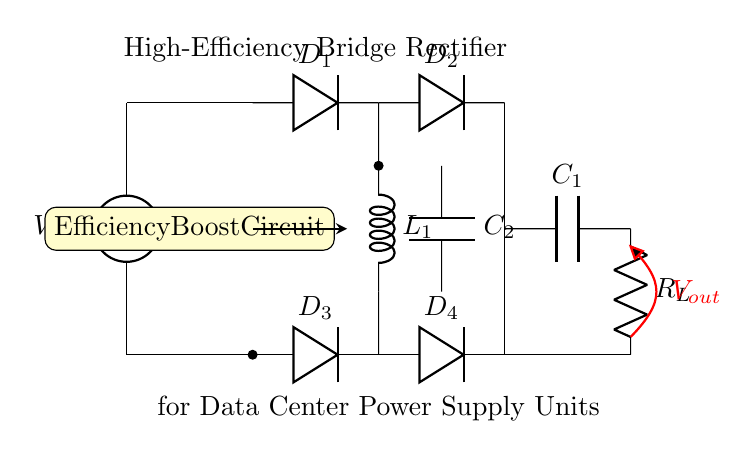What type of rectifier is shown in the circuit? The circuit features a bridge rectifier, which uses four diodes to convert AC voltage to DC voltage.
Answer: bridge rectifier How many diodes are in this circuit? The circuit shows a total of four diodes, labeled D1, D2, D3, and D4, which are part of the bridge rectifier configuration.
Answer: four What component is used for smoothing the output voltage? The smoothing is performed by the capacitor labeled C1, which helps reduce ripple in the output voltage.
Answer: C1 What is the purpose of the component labeled L1? L1 is an inductor which is utilized to enhance the efficiency of the rectifier by reducing the ripple current for better performance.
Answer: efficiency enhancement What is the function of the load resistor R_L? R_L serves as the load in the circuit, allowing current to flow and thereby simulating the operation of an actual load that the power supply would drive.
Answer: simulate a load What does the voltage label V_out indicate? V_out represents the output voltage of the rectifier circuit, which is the DC voltage supplied to the load after rectification and smoothing.
Answer: output voltage How does the efficiency boost circuit improve performance? The efficiency boost circuit, which includes components like L1 and C2, reduces losses during the rectification process by optimizing current flow and voltage stabilization.
Answer: reduces losses 